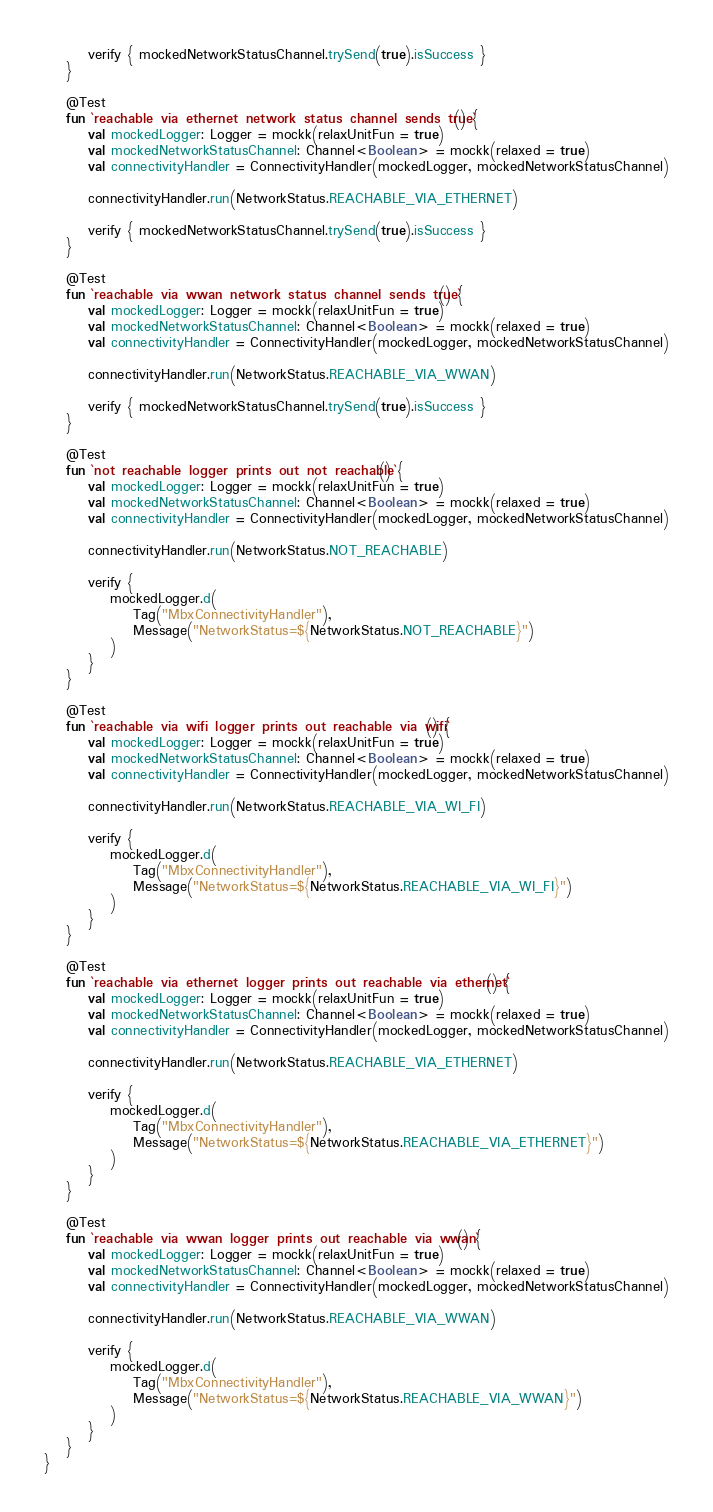<code> <loc_0><loc_0><loc_500><loc_500><_Kotlin_>        verify { mockedNetworkStatusChannel.trySend(true).isSuccess }
    }

    @Test
    fun `reachable via ethernet network status channel sends true`() {
        val mockedLogger: Logger = mockk(relaxUnitFun = true)
        val mockedNetworkStatusChannel: Channel<Boolean> = mockk(relaxed = true)
        val connectivityHandler = ConnectivityHandler(mockedLogger, mockedNetworkStatusChannel)

        connectivityHandler.run(NetworkStatus.REACHABLE_VIA_ETHERNET)

        verify { mockedNetworkStatusChannel.trySend(true).isSuccess }
    }

    @Test
    fun `reachable via wwan network status channel sends true`() {
        val mockedLogger: Logger = mockk(relaxUnitFun = true)
        val mockedNetworkStatusChannel: Channel<Boolean> = mockk(relaxed = true)
        val connectivityHandler = ConnectivityHandler(mockedLogger, mockedNetworkStatusChannel)

        connectivityHandler.run(NetworkStatus.REACHABLE_VIA_WWAN)

        verify { mockedNetworkStatusChannel.trySend(true).isSuccess }
    }

    @Test
    fun `not reachable logger prints out not reachable`() {
        val mockedLogger: Logger = mockk(relaxUnitFun = true)
        val mockedNetworkStatusChannel: Channel<Boolean> = mockk(relaxed = true)
        val connectivityHandler = ConnectivityHandler(mockedLogger, mockedNetworkStatusChannel)

        connectivityHandler.run(NetworkStatus.NOT_REACHABLE)

        verify {
            mockedLogger.d(
                Tag("MbxConnectivityHandler"),
                Message("NetworkStatus=${NetworkStatus.NOT_REACHABLE}")
            )
        }
    }

    @Test
    fun `reachable via wifi logger prints out reachable via wifi`() {
        val mockedLogger: Logger = mockk(relaxUnitFun = true)
        val mockedNetworkStatusChannel: Channel<Boolean> = mockk(relaxed = true)
        val connectivityHandler = ConnectivityHandler(mockedLogger, mockedNetworkStatusChannel)

        connectivityHandler.run(NetworkStatus.REACHABLE_VIA_WI_FI)

        verify {
            mockedLogger.d(
                Tag("MbxConnectivityHandler"),
                Message("NetworkStatus=${NetworkStatus.REACHABLE_VIA_WI_FI}")
            )
        }
    }

    @Test
    fun `reachable via ethernet logger prints out reachable via ethernet`() {
        val mockedLogger: Logger = mockk(relaxUnitFun = true)
        val mockedNetworkStatusChannel: Channel<Boolean> = mockk(relaxed = true)
        val connectivityHandler = ConnectivityHandler(mockedLogger, mockedNetworkStatusChannel)

        connectivityHandler.run(NetworkStatus.REACHABLE_VIA_ETHERNET)

        verify {
            mockedLogger.d(
                Tag("MbxConnectivityHandler"),
                Message("NetworkStatus=${NetworkStatus.REACHABLE_VIA_ETHERNET}")
            )
        }
    }

    @Test
    fun `reachable via wwan logger prints out reachable via wwan`() {
        val mockedLogger: Logger = mockk(relaxUnitFun = true)
        val mockedNetworkStatusChannel: Channel<Boolean> = mockk(relaxed = true)
        val connectivityHandler = ConnectivityHandler(mockedLogger, mockedNetworkStatusChannel)

        connectivityHandler.run(NetworkStatus.REACHABLE_VIA_WWAN)

        verify {
            mockedLogger.d(
                Tag("MbxConnectivityHandler"),
                Message("NetworkStatus=${NetworkStatus.REACHABLE_VIA_WWAN}")
            )
        }
    }
}
</code> 